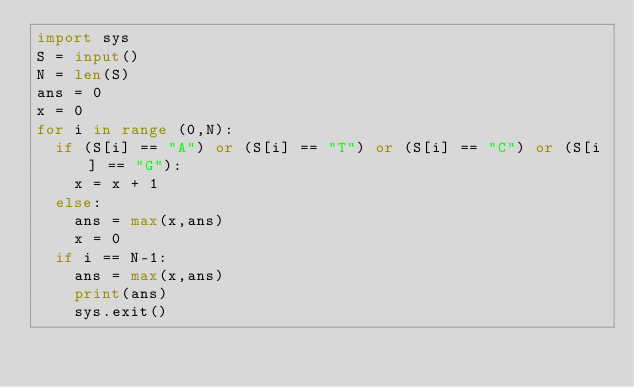Convert code to text. <code><loc_0><loc_0><loc_500><loc_500><_Python_>import sys
S = input()
N = len(S)
ans = 0
x = 0
for i in range (0,N):
  if (S[i] == "A") or (S[i] == "T") or (S[i] == "C") or (S[i] == "G"):
    x = x + 1
  else:
    ans = max(x,ans)
    x = 0
  if i == N-1:
    ans = max(x,ans)
    print(ans)
    sys.exit()</code> 